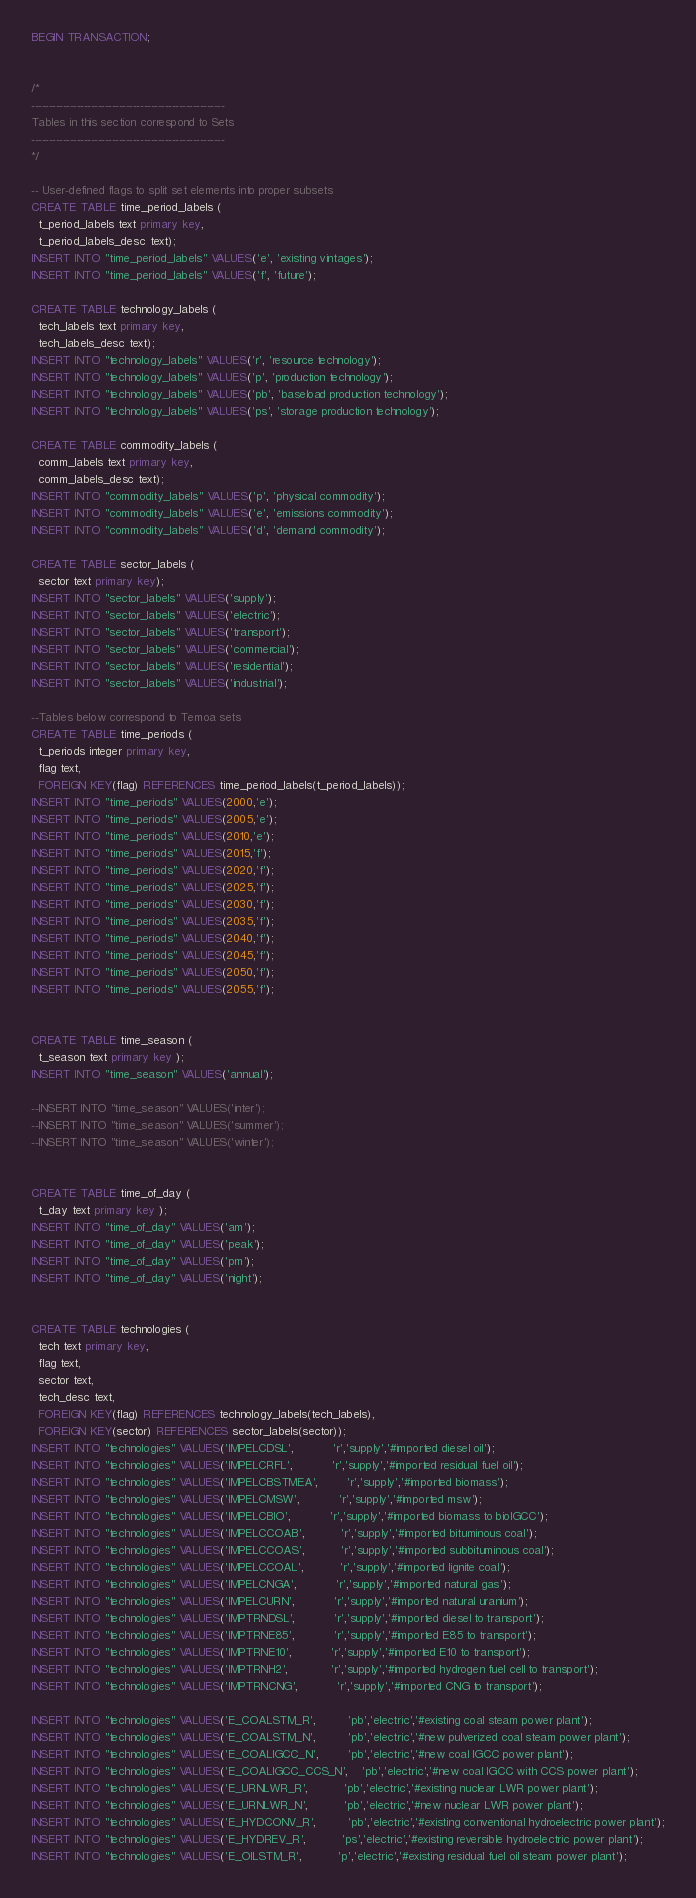Convert code to text. <code><loc_0><loc_0><loc_500><loc_500><_SQL_>BEGIN TRANSACTION;


/*
-------------------------------------------------------
Tables in this section correspond to Sets
-------------------------------------------------------
*/

-- User-defined flags to split set elements into proper subsets
CREATE TABLE time_period_labels (
  t_period_labels text primary key,
  t_period_labels_desc text);
INSERT INTO "time_period_labels" VALUES('e', 'existing vintages');
INSERT INTO "time_period_labels" VALUES('f', 'future');

CREATE TABLE technology_labels (
  tech_labels text primary key,
  tech_labels_desc text);
INSERT INTO "technology_labels" VALUES('r', 'resource technology');
INSERT INTO "technology_labels" VALUES('p', 'production technology');
INSERT INTO "technology_labels" VALUES('pb', 'baseload production technology');
INSERT INTO "technology_labels" VALUES('ps', 'storage production technology');

CREATE TABLE commodity_labels (
  comm_labels text primary key,
  comm_labels_desc text);
INSERT INTO "commodity_labels" VALUES('p', 'physical commodity');
INSERT INTO "commodity_labels" VALUES('e', 'emissions commodity');
INSERT INTO "commodity_labels" VALUES('d', 'demand commodity');

CREATE TABLE sector_labels (
  sector text primary key);
INSERT INTO "sector_labels" VALUES('supply');
INSERT INTO "sector_labels" VALUES('electric');
INSERT INTO "sector_labels" VALUES('transport');
INSERT INTO "sector_labels" VALUES('commercial');
INSERT INTO "sector_labels" VALUES('residential');
INSERT INTO "sector_labels" VALUES('industrial');

--Tables below correspond to Temoa sets
CREATE TABLE time_periods (
  t_periods integer primary key,
  flag text,
  FOREIGN KEY(flag) REFERENCES time_period_labels(t_period_labels)); 
INSERT INTO "time_periods" VALUES(2000,'e');  
INSERT INTO "time_periods" VALUES(2005,'e');  
INSERT INTO "time_periods" VALUES(2010,'e');  
INSERT INTO "time_periods" VALUES(2015,'f');
INSERT INTO "time_periods" VALUES(2020,'f');
INSERT INTO "time_periods" VALUES(2025,'f');
INSERT INTO "time_periods" VALUES(2030,'f');
INSERT INTO "time_periods" VALUES(2035,'f');
INSERT INTO "time_periods" VALUES(2040,'f');
INSERT INTO "time_periods" VALUES(2045,'f');
INSERT INTO "time_periods" VALUES(2050,'f');
INSERT INTO "time_periods" VALUES(2055,'f');


CREATE TABLE time_season (
  t_season text primary key );
INSERT INTO "time_season" VALUES('annual'); 

--INSERT INTO "time_season" VALUES('inter');
--INSERT INTO "time_season" VALUES('summer');
--INSERT INTO "time_season" VALUES('winter');


CREATE TABLE time_of_day (
  t_day text primary key );
INSERT INTO "time_of_day" VALUES('am');
INSERT INTO "time_of_day" VALUES('peak');
INSERT INTO "time_of_day" VALUES('pm');
INSERT INTO "time_of_day" VALUES('night');


CREATE TABLE technologies (
  tech text primary key,
  flag text,
  sector text,
  tech_desc text,
  FOREIGN KEY(flag) REFERENCES technology_labels(tech_labels),
  FOREIGN KEY(sector) REFERENCES sector_labels(sector));
INSERT INTO "technologies" VALUES('IMPELCDSL',           'r','supply','#imported diesel oil');
INSERT INTO "technologies" VALUES('IMPELCRFL',           'r','supply','#imported residual fuel oil');
INSERT INTO "technologies" VALUES('IMPELCBSTMEA',        'r','supply','#imported biomass');
INSERT INTO "technologies" VALUES('IMPELCMSW',           'r','supply','#imported msw');
INSERT INTO "technologies" VALUES('IMPELCBIO',           'r','supply','#imported biomass to bioIGCC');
INSERT INTO "technologies" VALUES('IMPELCCOAB',          'r','supply','#imported bituminous coal');
INSERT INTO "technologies" VALUES('IMPELCCOAS',          'r','supply','#imported subbituminous coal');
INSERT INTO "technologies" VALUES('IMPELCCOAL',          'r','supply','#imported lignite coal');
INSERT INTO "technologies" VALUES('IMPELCNGA',           'r','supply','#imported natural gas');
INSERT INTO "technologies" VALUES('IMPELCURN',           'r','supply','#imported natural uranium');
INSERT INTO "technologies" VALUES('IMPTRNDSL',           'r','supply','#imported diesel to transport');
INSERT INTO "technologies" VALUES('IMPTRNE85',           'r','supply','#imported E85 to transport');
INSERT INTO "technologies" VALUES('IMPTRNE10',           'r','supply','#imported E10 to transport');
INSERT INTO "technologies" VALUES('IMPTRNH2',            'r','supply','#imported hydrogen fuel cell to transport');
INSERT INTO "technologies" VALUES('IMPTRNCNG',           'r','supply','#imported CNG to transport');

INSERT INTO "technologies" VALUES('E_COALSTM_R',         'pb','electric','#existing coal steam power plant');
INSERT INTO "technologies" VALUES('E_COALSTM_N',         'pb','electric','#new pulverized coal steam power plant');
INSERT INTO "technologies" VALUES('E_COALIGCC_N',        'pb','electric','#new coal IGCC power plant');
INSERT INTO "technologies" VALUES('E_COALIGCC_CCS_N',    'pb','electric','#new coal IGCC with CCS power plant');
INSERT INTO "technologies" VALUES('E_URNLWR_R',          'pb','electric','#existing nuclear LWR power plant');
INSERT INTO "technologies" VALUES('E_URNLWR_N',          'pb','electric','#new nuclear LWR power plant');
INSERT INTO "technologies" VALUES('E_HYDCONV_R',         'pb','electric','#existing conventional hydroelectric power plant');
INSERT INTO "technologies" VALUES('E_HYDREV_R',          'ps','electric','#existing reversible hydroelectric power plant');
INSERT INTO "technologies" VALUES('E_OILSTM_R',          'p','electric','#existing residual fuel oil steam power plant');</code> 